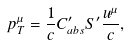Convert formula to latex. <formula><loc_0><loc_0><loc_500><loc_500>p ^ { \mu } _ { T } = \frac { 1 } { c } C ^ { \prime } _ { a b s } S ^ { \prime } \frac { u ^ { \mu } } { c } ,</formula> 